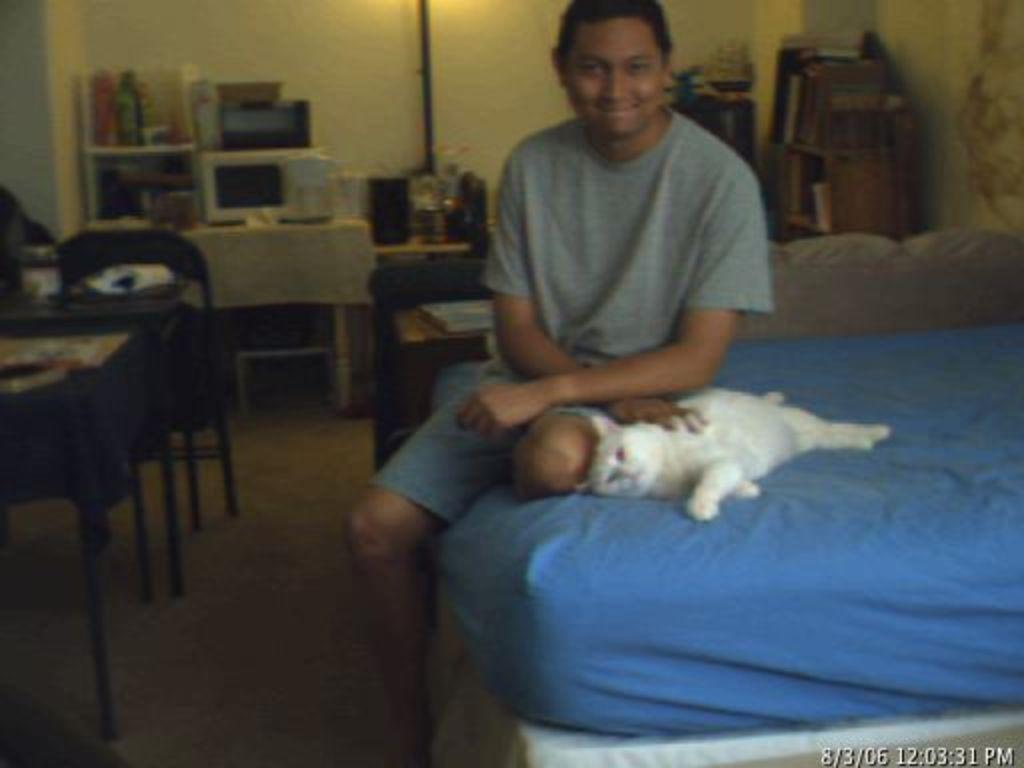Who is present in the image? There is a man in the image. What is the man doing in the image? The man is sitting on the bed. What is the man wearing in the image? The man is wearing a t-shirt. What other living creature is present in the image? There is a cat in the image. What color is the cat in the image? The cat is white in color. What is the cat doing in the image? The cat is sleeping on the bed. What type of notebook is the man using to take notes in the image? There is no notebook present in the image, and the man is not taking notes. 